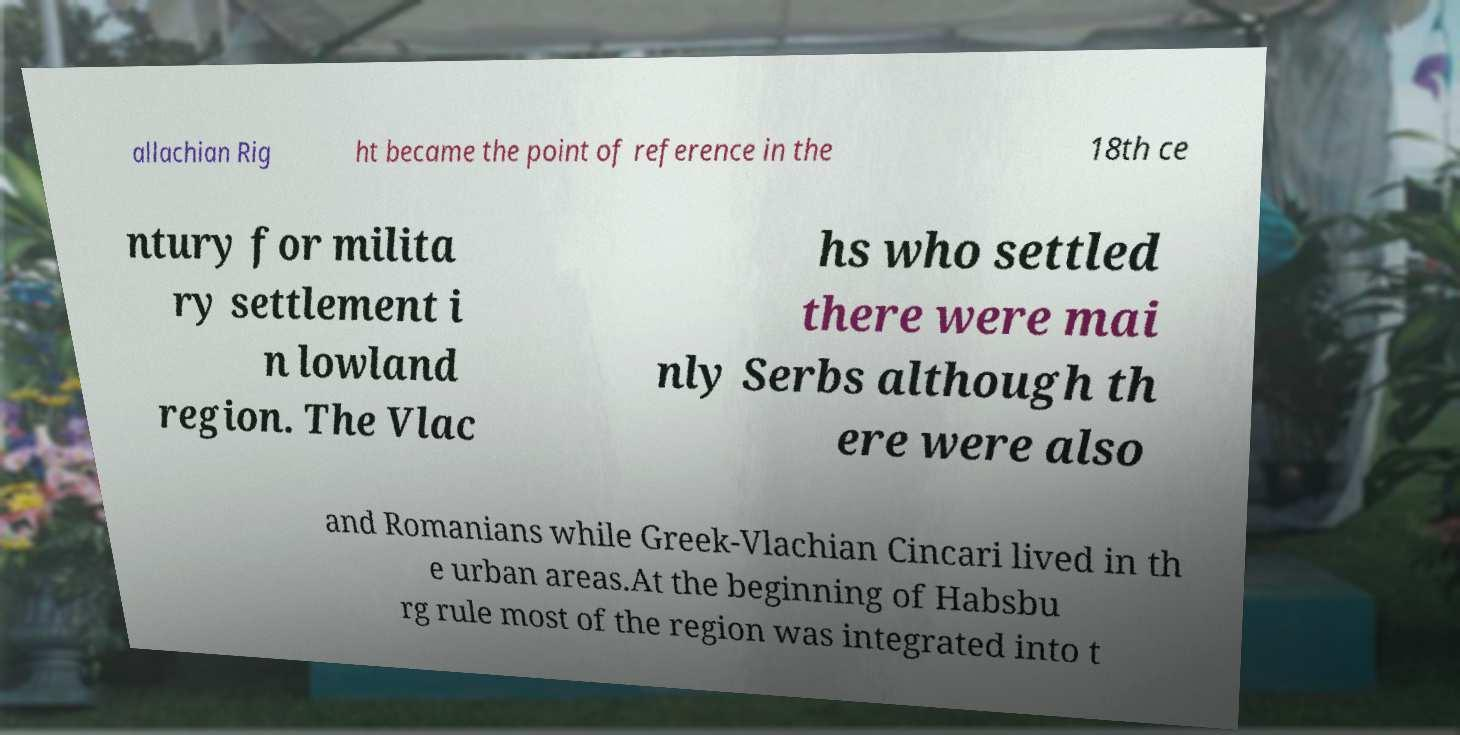Could you assist in decoding the text presented in this image and type it out clearly? allachian Rig ht became the point of reference in the 18th ce ntury for milita ry settlement i n lowland region. The Vlac hs who settled there were mai nly Serbs although th ere were also and Romanians while Greek-Vlachian Cincari lived in th e urban areas.At the beginning of Habsbu rg rule most of the region was integrated into t 